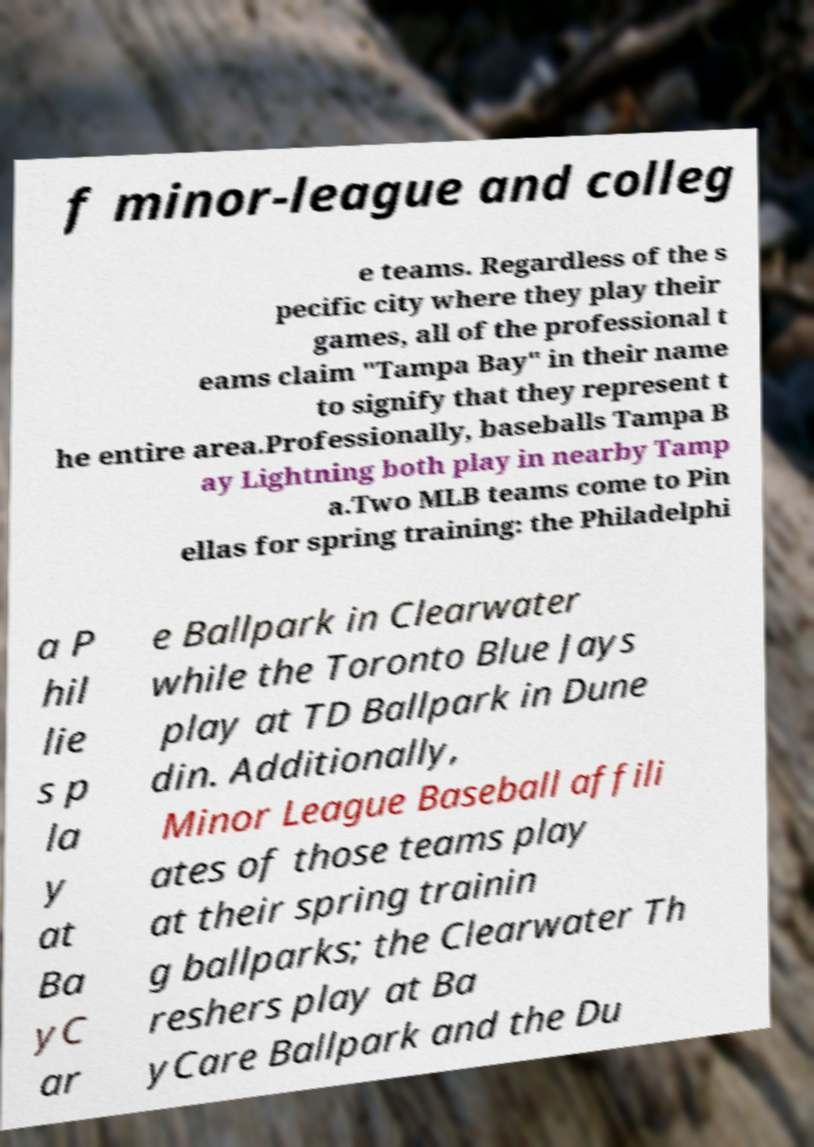There's text embedded in this image that I need extracted. Can you transcribe it verbatim? f minor-league and colleg e teams. Regardless of the s pecific city where they play their games, all of the professional t eams claim "Tampa Bay" in their name to signify that they represent t he entire area.Professionally, baseballs Tampa B ay Lightning both play in nearby Tamp a.Two MLB teams come to Pin ellas for spring training: the Philadelphi a P hil lie s p la y at Ba yC ar e Ballpark in Clearwater while the Toronto Blue Jays play at TD Ballpark in Dune din. Additionally, Minor League Baseball affili ates of those teams play at their spring trainin g ballparks; the Clearwater Th reshers play at Ba yCare Ballpark and the Du 